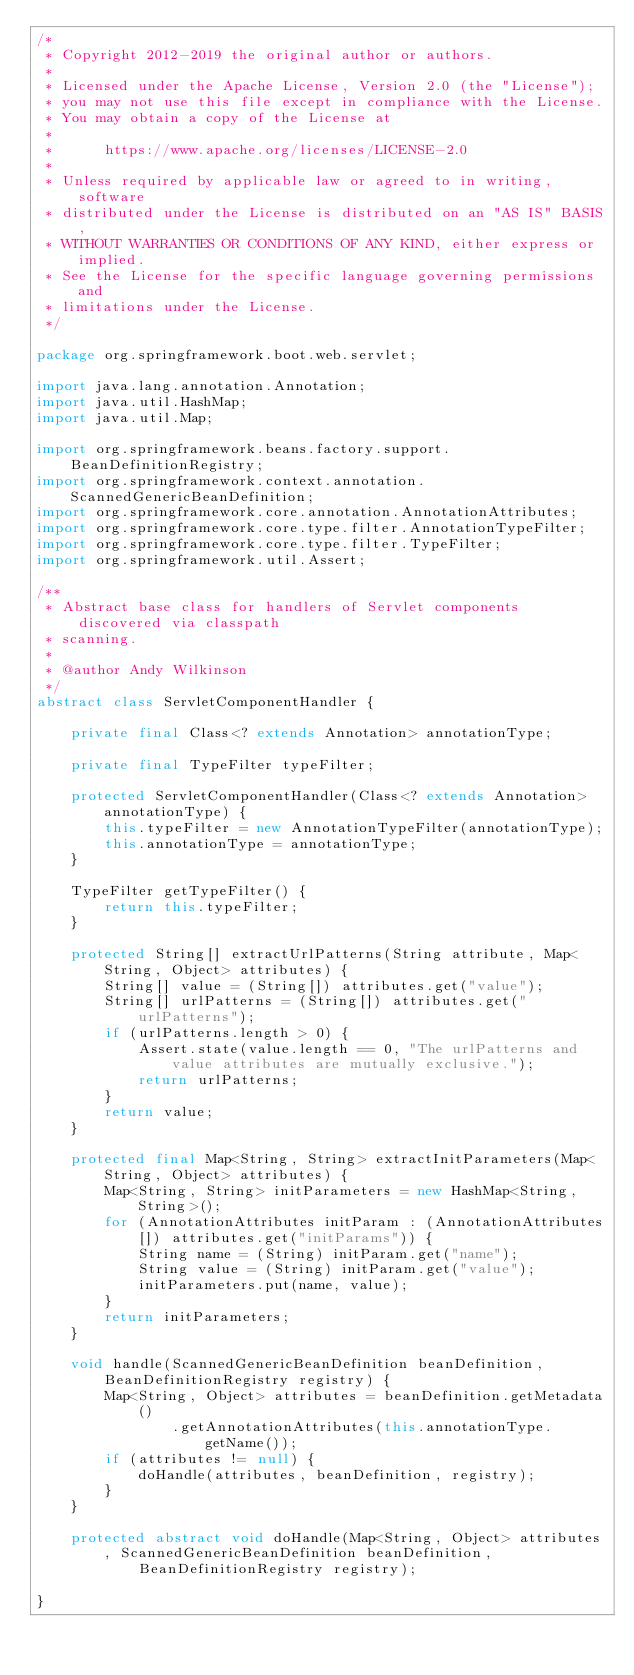<code> <loc_0><loc_0><loc_500><loc_500><_Java_>/*
 * Copyright 2012-2019 the original author or authors.
 *
 * Licensed under the Apache License, Version 2.0 (the "License");
 * you may not use this file except in compliance with the License.
 * You may obtain a copy of the License at
 *
 *      https://www.apache.org/licenses/LICENSE-2.0
 *
 * Unless required by applicable law or agreed to in writing, software
 * distributed under the License is distributed on an "AS IS" BASIS,
 * WITHOUT WARRANTIES OR CONDITIONS OF ANY KIND, either express or implied.
 * See the License for the specific language governing permissions and
 * limitations under the License.
 */

package org.springframework.boot.web.servlet;

import java.lang.annotation.Annotation;
import java.util.HashMap;
import java.util.Map;

import org.springframework.beans.factory.support.BeanDefinitionRegistry;
import org.springframework.context.annotation.ScannedGenericBeanDefinition;
import org.springframework.core.annotation.AnnotationAttributes;
import org.springframework.core.type.filter.AnnotationTypeFilter;
import org.springframework.core.type.filter.TypeFilter;
import org.springframework.util.Assert;

/**
 * Abstract base class for handlers of Servlet components discovered via classpath
 * scanning.
 *
 * @author Andy Wilkinson
 */
abstract class ServletComponentHandler {

	private final Class<? extends Annotation> annotationType;

	private final TypeFilter typeFilter;

	protected ServletComponentHandler(Class<? extends Annotation> annotationType) {
		this.typeFilter = new AnnotationTypeFilter(annotationType);
		this.annotationType = annotationType;
	}

	TypeFilter getTypeFilter() {
		return this.typeFilter;
	}

	protected String[] extractUrlPatterns(String attribute, Map<String, Object> attributes) {
		String[] value = (String[]) attributes.get("value");
		String[] urlPatterns = (String[]) attributes.get("urlPatterns");
		if (urlPatterns.length > 0) {
			Assert.state(value.length == 0, "The urlPatterns and value attributes are mutually exclusive.");
			return urlPatterns;
		}
		return value;
	}

	protected final Map<String, String> extractInitParameters(Map<String, Object> attributes) {
		Map<String, String> initParameters = new HashMap<String, String>();
		for (AnnotationAttributes initParam : (AnnotationAttributes[]) attributes.get("initParams")) {
			String name = (String) initParam.get("name");
			String value = (String) initParam.get("value");
			initParameters.put(name, value);
		}
		return initParameters;
	}

	void handle(ScannedGenericBeanDefinition beanDefinition, BeanDefinitionRegistry registry) {
		Map<String, Object> attributes = beanDefinition.getMetadata()
				.getAnnotationAttributes(this.annotationType.getName());
		if (attributes != null) {
			doHandle(attributes, beanDefinition, registry);
		}
	}

	protected abstract void doHandle(Map<String, Object> attributes, ScannedGenericBeanDefinition beanDefinition,
			BeanDefinitionRegistry registry);

}
</code> 